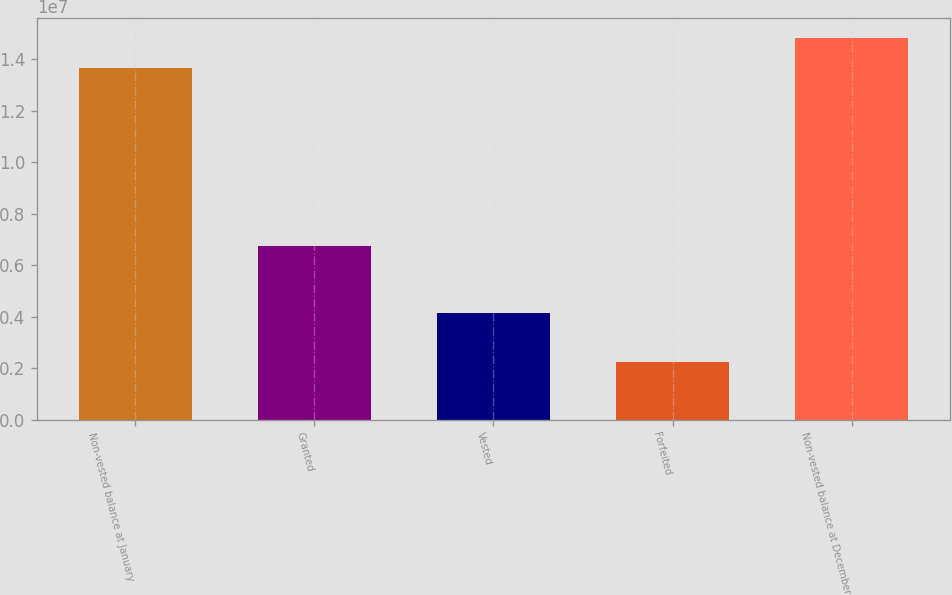Convert chart. <chart><loc_0><loc_0><loc_500><loc_500><bar_chart><fcel>Non-vested balance at January<fcel>Granted<fcel>Vested<fcel>Forfeited<fcel>Non-vested balance at December<nl><fcel>1.36745e+07<fcel>6.73401e+06<fcel>4.16421e+06<fcel>2.22401e+06<fcel>1.48541e+07<nl></chart> 